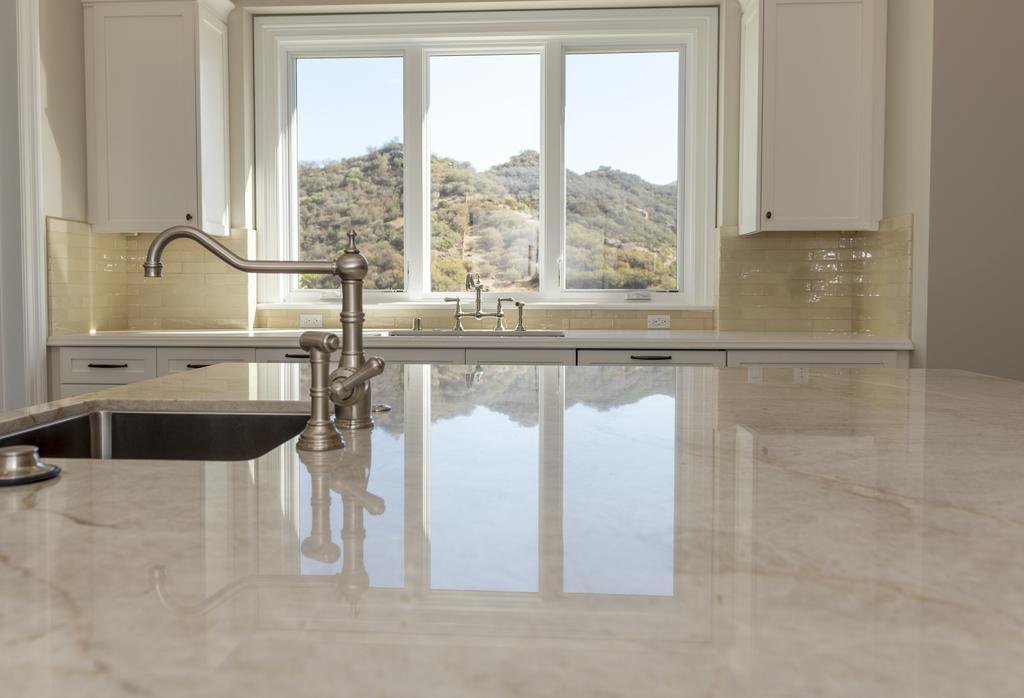Please provide a concise description of this image. In the picture I can see kitchen tops which has a sinks and taps on them. In the background I can see cupboards, windows, trees, the sky and some other objects. 